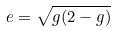Convert formula to latex. <formula><loc_0><loc_0><loc_500><loc_500>e = \sqrt { g ( 2 - g ) }</formula> 